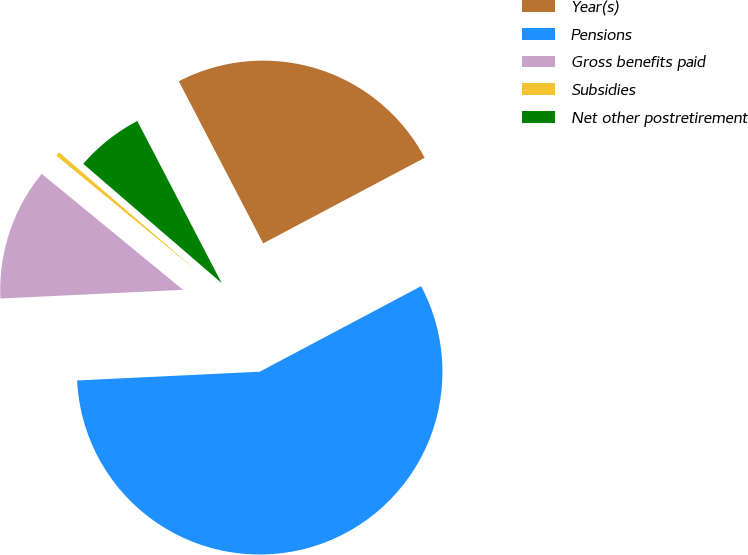Convert chart. <chart><loc_0><loc_0><loc_500><loc_500><pie_chart><fcel>Year(s)<fcel>Pensions<fcel>Gross benefits paid<fcel>Subsidies<fcel>Net other postretirement<nl><fcel>24.88%<fcel>56.99%<fcel>11.7%<fcel>0.38%<fcel>6.04%<nl></chart> 